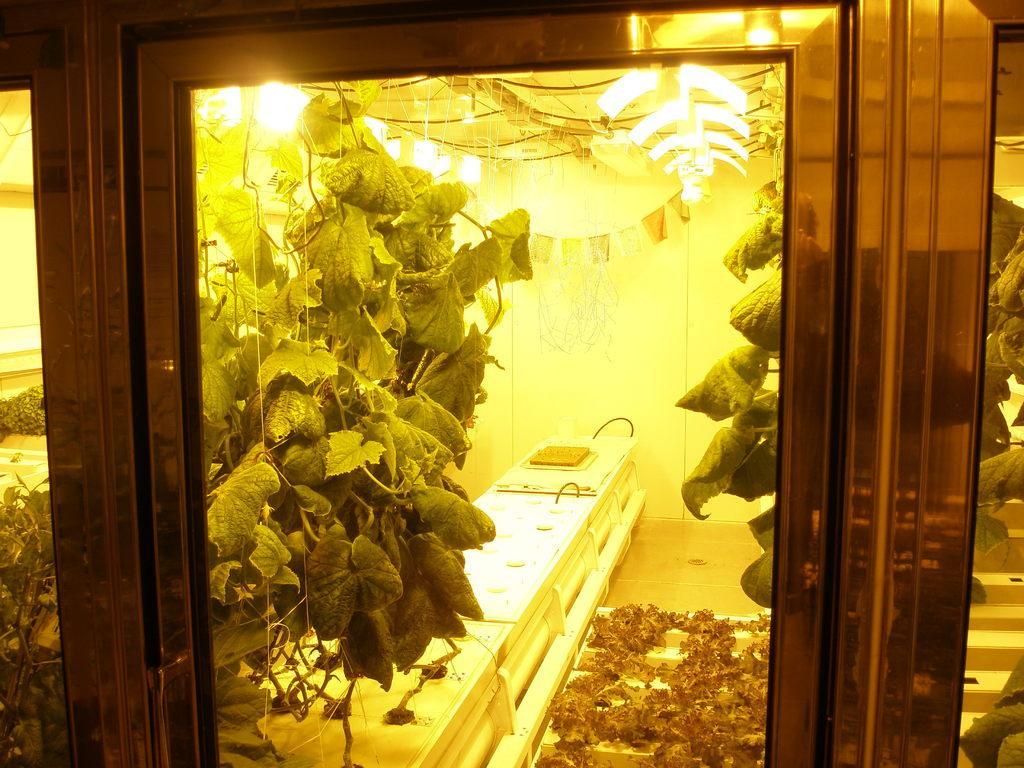How would you summarize this image in a sentence or two? In this picture we can see a glass door and behind the door there are leaves and other things. Behind the leaves there is a wall and there are lights on the top. 